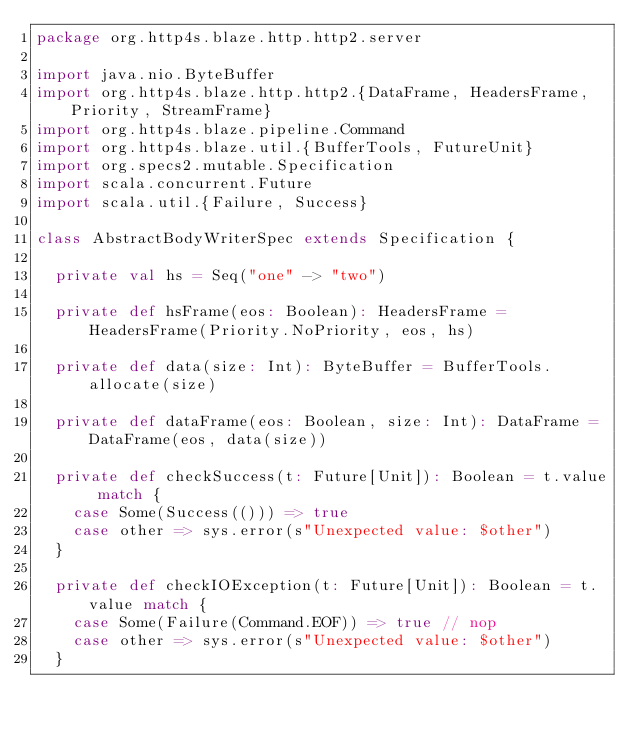Convert code to text. <code><loc_0><loc_0><loc_500><loc_500><_Scala_>package org.http4s.blaze.http.http2.server

import java.nio.ByteBuffer
import org.http4s.blaze.http.http2.{DataFrame, HeadersFrame, Priority, StreamFrame}
import org.http4s.blaze.pipeline.Command
import org.http4s.blaze.util.{BufferTools, FutureUnit}
import org.specs2.mutable.Specification
import scala.concurrent.Future
import scala.util.{Failure, Success}

class AbstractBodyWriterSpec extends Specification {

  private val hs = Seq("one" -> "two")

  private def hsFrame(eos: Boolean): HeadersFrame = HeadersFrame(Priority.NoPriority, eos, hs)

  private def data(size: Int): ByteBuffer = BufferTools.allocate(size)

  private def dataFrame(eos: Boolean, size: Int): DataFrame = DataFrame(eos, data(size))

  private def checkSuccess(t: Future[Unit]): Boolean = t.value match {
    case Some(Success(())) => true
    case other => sys.error(s"Unexpected value: $other")
  }

  private def checkIOException(t: Future[Unit]): Boolean = t.value match {
    case Some(Failure(Command.EOF)) => true // nop
    case other => sys.error(s"Unexpected value: $other")
  }
</code> 